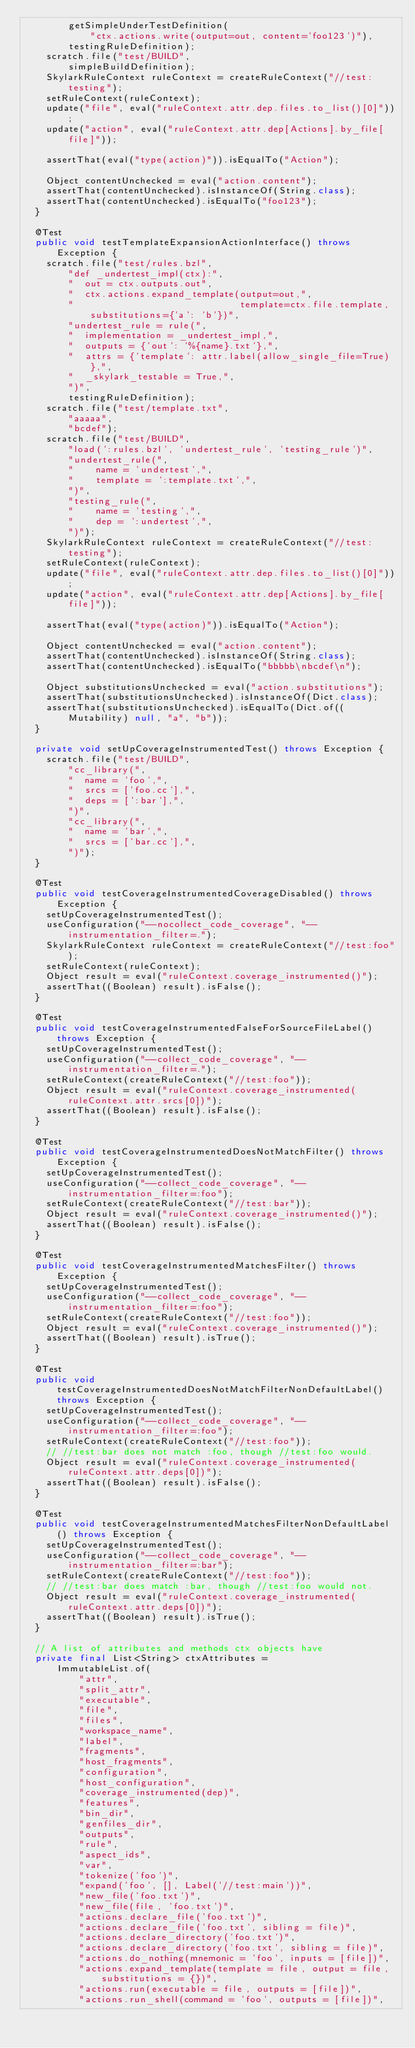<code> <loc_0><loc_0><loc_500><loc_500><_Java_>        getSimpleUnderTestDefinition(
            "ctx.actions.write(output=out, content='foo123')"),
        testingRuleDefinition);
    scratch.file("test/BUILD",
        simpleBuildDefinition);
    SkylarkRuleContext ruleContext = createRuleContext("//test:testing");
    setRuleContext(ruleContext);
    update("file", eval("ruleContext.attr.dep.files.to_list()[0]"));
    update("action", eval("ruleContext.attr.dep[Actions].by_file[file]"));

    assertThat(eval("type(action)")).isEqualTo("Action");

    Object contentUnchecked = eval("action.content");
    assertThat(contentUnchecked).isInstanceOf(String.class);
    assertThat(contentUnchecked).isEqualTo("foo123");
  }

  @Test
  public void testTemplateExpansionActionInterface() throws Exception {
    scratch.file("test/rules.bzl",
        "def _undertest_impl(ctx):",
        "  out = ctx.outputs.out",
        "  ctx.actions.expand_template(output=out,",
        "                              template=ctx.file.template, substitutions={'a': 'b'})",
        "undertest_rule = rule(",
        "  implementation = _undertest_impl,",
        "  outputs = {'out': '%{name}.txt'},",
        "  attrs = {'template': attr.label(allow_single_file=True)},",
        "  _skylark_testable = True,",
        ")",
        testingRuleDefinition);
    scratch.file("test/template.txt",
        "aaaaa",
        "bcdef");
    scratch.file("test/BUILD",
        "load(':rules.bzl', 'undertest_rule', 'testing_rule')",
        "undertest_rule(",
        "    name = 'undertest',",
        "    template = ':template.txt',",
        ")",
        "testing_rule(",
        "    name = 'testing',",
        "    dep = ':undertest',",
        ")");
    SkylarkRuleContext ruleContext = createRuleContext("//test:testing");
    setRuleContext(ruleContext);
    update("file", eval("ruleContext.attr.dep.files.to_list()[0]"));
    update("action", eval("ruleContext.attr.dep[Actions].by_file[file]"));

    assertThat(eval("type(action)")).isEqualTo("Action");

    Object contentUnchecked = eval("action.content");
    assertThat(contentUnchecked).isInstanceOf(String.class);
    assertThat(contentUnchecked).isEqualTo("bbbbb\nbcdef\n");

    Object substitutionsUnchecked = eval("action.substitutions");
    assertThat(substitutionsUnchecked).isInstanceOf(Dict.class);
    assertThat(substitutionsUnchecked).isEqualTo(Dict.of((Mutability) null, "a", "b"));
  }

  private void setUpCoverageInstrumentedTest() throws Exception {
    scratch.file("test/BUILD",
        "cc_library(",
        "  name = 'foo',",
        "  srcs = ['foo.cc'],",
        "  deps = [':bar'],",
        ")",
        "cc_library(",
        "  name = 'bar',",
        "  srcs = ['bar.cc'],",
        ")");
  }

  @Test
  public void testCoverageInstrumentedCoverageDisabled() throws Exception {
    setUpCoverageInstrumentedTest();
    useConfiguration("--nocollect_code_coverage", "--instrumentation_filter=.");
    SkylarkRuleContext ruleContext = createRuleContext("//test:foo");
    setRuleContext(ruleContext);
    Object result = eval("ruleContext.coverage_instrumented()");
    assertThat((Boolean) result).isFalse();
  }

  @Test
  public void testCoverageInstrumentedFalseForSourceFileLabel() throws Exception {
    setUpCoverageInstrumentedTest();
    useConfiguration("--collect_code_coverage", "--instrumentation_filter=.");
    setRuleContext(createRuleContext("//test:foo"));
    Object result = eval("ruleContext.coverage_instrumented(ruleContext.attr.srcs[0])");
    assertThat((Boolean) result).isFalse();
  }

  @Test
  public void testCoverageInstrumentedDoesNotMatchFilter() throws Exception {
    setUpCoverageInstrumentedTest();
    useConfiguration("--collect_code_coverage", "--instrumentation_filter=:foo");
    setRuleContext(createRuleContext("//test:bar"));
    Object result = eval("ruleContext.coverage_instrumented()");
    assertThat((Boolean) result).isFalse();
  }

  @Test
  public void testCoverageInstrumentedMatchesFilter() throws Exception {
    setUpCoverageInstrumentedTest();
    useConfiguration("--collect_code_coverage", "--instrumentation_filter=:foo");
    setRuleContext(createRuleContext("//test:foo"));
    Object result = eval("ruleContext.coverage_instrumented()");
    assertThat((Boolean) result).isTrue();
  }

  @Test
  public void testCoverageInstrumentedDoesNotMatchFilterNonDefaultLabel() throws Exception {
    setUpCoverageInstrumentedTest();
    useConfiguration("--collect_code_coverage", "--instrumentation_filter=:foo");
    setRuleContext(createRuleContext("//test:foo"));
    // //test:bar does not match :foo, though //test:foo would.
    Object result = eval("ruleContext.coverage_instrumented(ruleContext.attr.deps[0])");
    assertThat((Boolean) result).isFalse();
  }

  @Test
  public void testCoverageInstrumentedMatchesFilterNonDefaultLabel() throws Exception {
    setUpCoverageInstrumentedTest();
    useConfiguration("--collect_code_coverage", "--instrumentation_filter=:bar");
    setRuleContext(createRuleContext("//test:foo"));
    // //test:bar does match :bar, though //test:foo would not.
    Object result = eval("ruleContext.coverage_instrumented(ruleContext.attr.deps[0])");
    assertThat((Boolean) result).isTrue();
  }

  // A list of attributes and methods ctx objects have
  private final List<String> ctxAttributes =
      ImmutableList.of(
          "attr",
          "split_attr",
          "executable",
          "file",
          "files",
          "workspace_name",
          "label",
          "fragments",
          "host_fragments",
          "configuration",
          "host_configuration",
          "coverage_instrumented(dep)",
          "features",
          "bin_dir",
          "genfiles_dir",
          "outputs",
          "rule",
          "aspect_ids",
          "var",
          "tokenize('foo')",
          "expand('foo', [], Label('//test:main'))",
          "new_file('foo.txt')",
          "new_file(file, 'foo.txt')",
          "actions.declare_file('foo.txt')",
          "actions.declare_file('foo.txt', sibling = file)",
          "actions.declare_directory('foo.txt')",
          "actions.declare_directory('foo.txt', sibling = file)",
          "actions.do_nothing(mnemonic = 'foo', inputs = [file])",
          "actions.expand_template(template = file, output = file, substitutions = {})",
          "actions.run(executable = file, outputs = [file])",
          "actions.run_shell(command = 'foo', outputs = [file])",</code> 